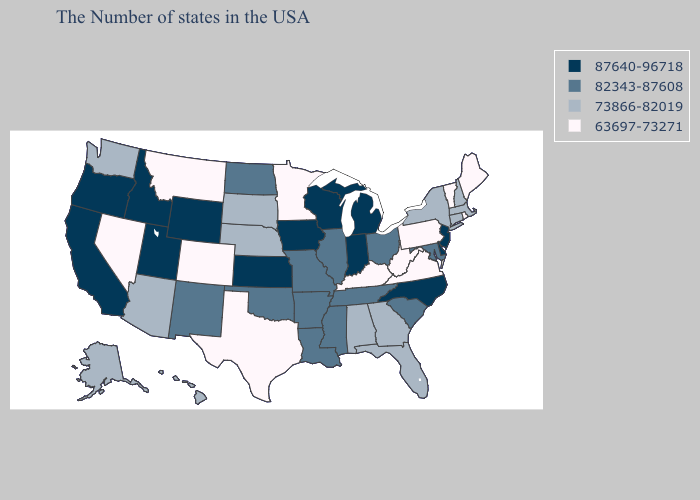Does the first symbol in the legend represent the smallest category?
Keep it brief. No. Name the states that have a value in the range 87640-96718?
Answer briefly. New Jersey, Delaware, North Carolina, Michigan, Indiana, Wisconsin, Iowa, Kansas, Wyoming, Utah, Idaho, California, Oregon. Name the states that have a value in the range 73866-82019?
Write a very short answer. Massachusetts, New Hampshire, Connecticut, New York, Florida, Georgia, Alabama, Nebraska, South Dakota, Arizona, Washington, Alaska, Hawaii. Among the states that border Rhode Island , which have the highest value?
Short answer required. Massachusetts, Connecticut. Does Alabama have the highest value in the USA?
Write a very short answer. No. Does the map have missing data?
Quick response, please. No. Does Utah have the lowest value in the USA?
Concise answer only. No. Does Kansas have the same value as Oregon?
Quick response, please. Yes. What is the lowest value in states that border California?
Be succinct. 63697-73271. What is the value of North Dakota?
Short answer required. 82343-87608. Does Massachusetts have the lowest value in the Northeast?
Concise answer only. No. Among the states that border Arizona , does Nevada have the lowest value?
Write a very short answer. Yes. What is the highest value in the MidWest ?
Give a very brief answer. 87640-96718. Which states have the lowest value in the MidWest?
Give a very brief answer. Minnesota. What is the lowest value in the USA?
Short answer required. 63697-73271. 